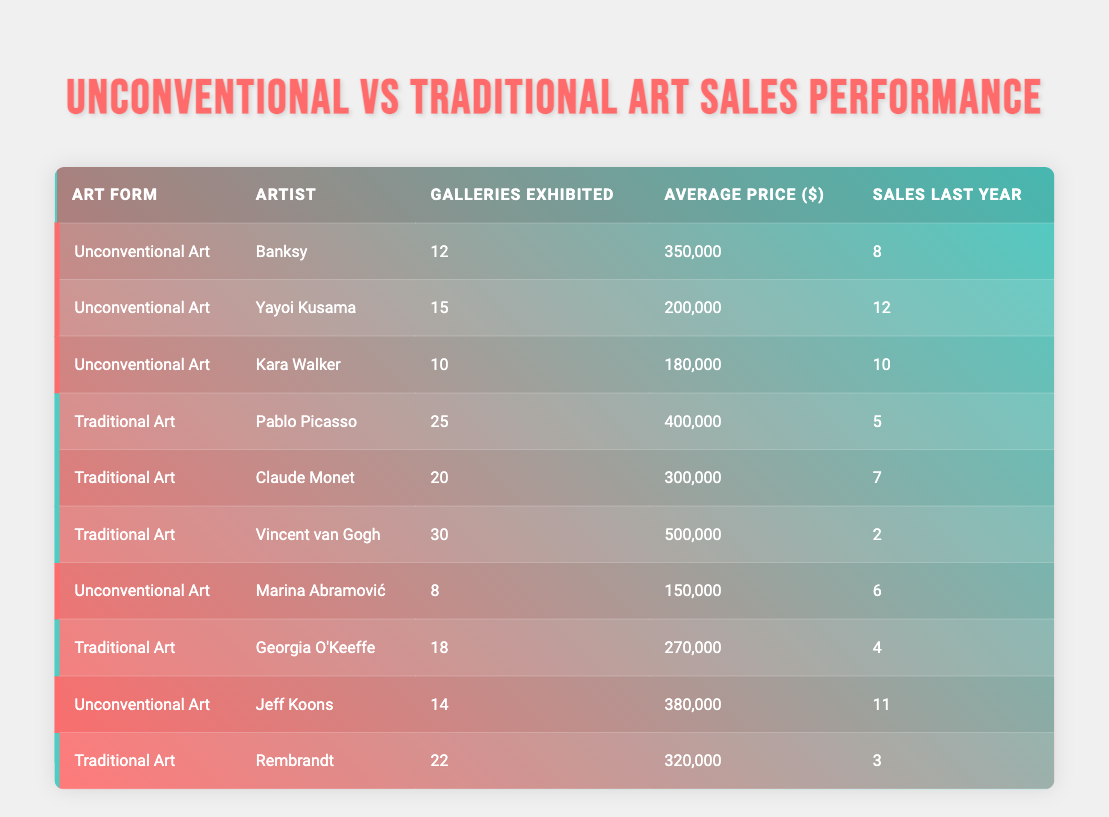What is the average sales last year for Unconventional Art? In the table, the sales last year for Unconventional Art artists are 8, 12, 10, 6, and 11. Summing them gives 8 + 12 + 10 + 6 + 11 = 47. There are 5 data points (artists), so the average is 47 divided by 5, which results in 9.4.
Answer: 9.4 Which artist had the highest average price among the Traditional Art forms? The average prices listed for Traditional Art are 400000 (Pablo Picasso), 300000 (Claude Monet), 500000 (Vincent van Gogh), 270000 (Georgia O'Keeffe), and 320000 (Rembrandt). The highest value is 500000, attributed to Vincent van Gogh.
Answer: Vincent van Gogh Is it true that all Unconventional Art artists exhibited in fewer galleries than the Traditional Art artists? Analyzing the data, Unconventional Art artists exhibited in 12, 15, 10, 8, and 14 galleries, while Traditional Art artists exhibited in 25, 20, 30, 18, and 22 galleries. The maximum number for Unconventional Art (15) is less than the minimum for Traditional Art (18). Therefore, the statement is true.
Answer: Yes What is the total number of sales made by artists in Traditional Art? The sales made in Traditional Art are 5 (Picasso), 7 (Monet), 2 (van Gogh), 4 (O'Keeffe), and 3 (Rembrandt). Adding these together gives 5 + 7 + 2 + 4 + 3 = 21.
Answer: 21 Who had more sales last year: Yayoi Kusama or Georgia O'Keeffe? Yayoi Kusama's sales last year were 12, while Georgia O'Keeffe's sales were 4. Comparing these values shows that Kusama had significantly more sales than O'Keeffe.
Answer: Yayoi Kusama What is the median number of galleries exhibited for all artists? To find the median, we first list all gallery counts: 12, 15, 10, 25, 20, 30, 8, 18, 14, 22. Sorting the values gives: 8, 10, 12, 14, 15, 18, 20, 22, 25, 30. There are 10 total, thus the median is (15 + 18) / 2 = 16.5.
Answer: 16.5 Do any Unconventional Art artists have sales last year equal to 10? The last year's sales figures for Unconventional Art artists are 8, 12, 10, 6, and 11. One artist (Kara Walker) has sales of exactly 10, which confirms that the statement is true.
Answer: Yes Which art form collectively had higher average prices based on the data? The average prices for Unconventional Art are 350000, 200000, 180000, 150000, and 380000. Summing these gives 1260000 and dividing by 5 results in 252000. For Traditional Art, the averages are 400000, 300000, 500000, 270000, and 320000. Summing these gives 1790000 and dividing by 5 results in 358000. Comparing both averages shows Traditional Art has a higher average price.
Answer: Traditional Art 